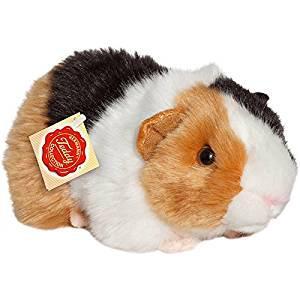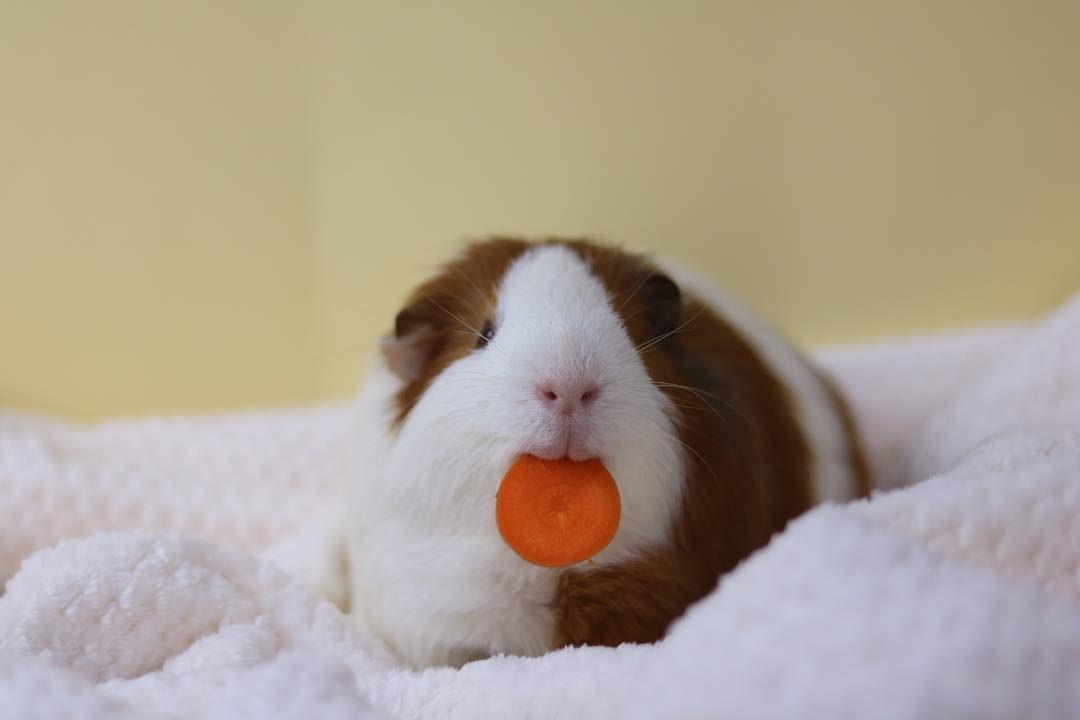The first image is the image on the left, the second image is the image on the right. Examine the images to the left and right. Is the description "There is at least one Guinea pig with an object in it's mouth." accurate? Answer yes or no. Yes. The first image is the image on the left, the second image is the image on the right. Considering the images on both sides, is "Each image contains exactly one guinea pig figure, and one image shows a guinea pig on a plush white textured fabric." valid? Answer yes or no. Yes. 